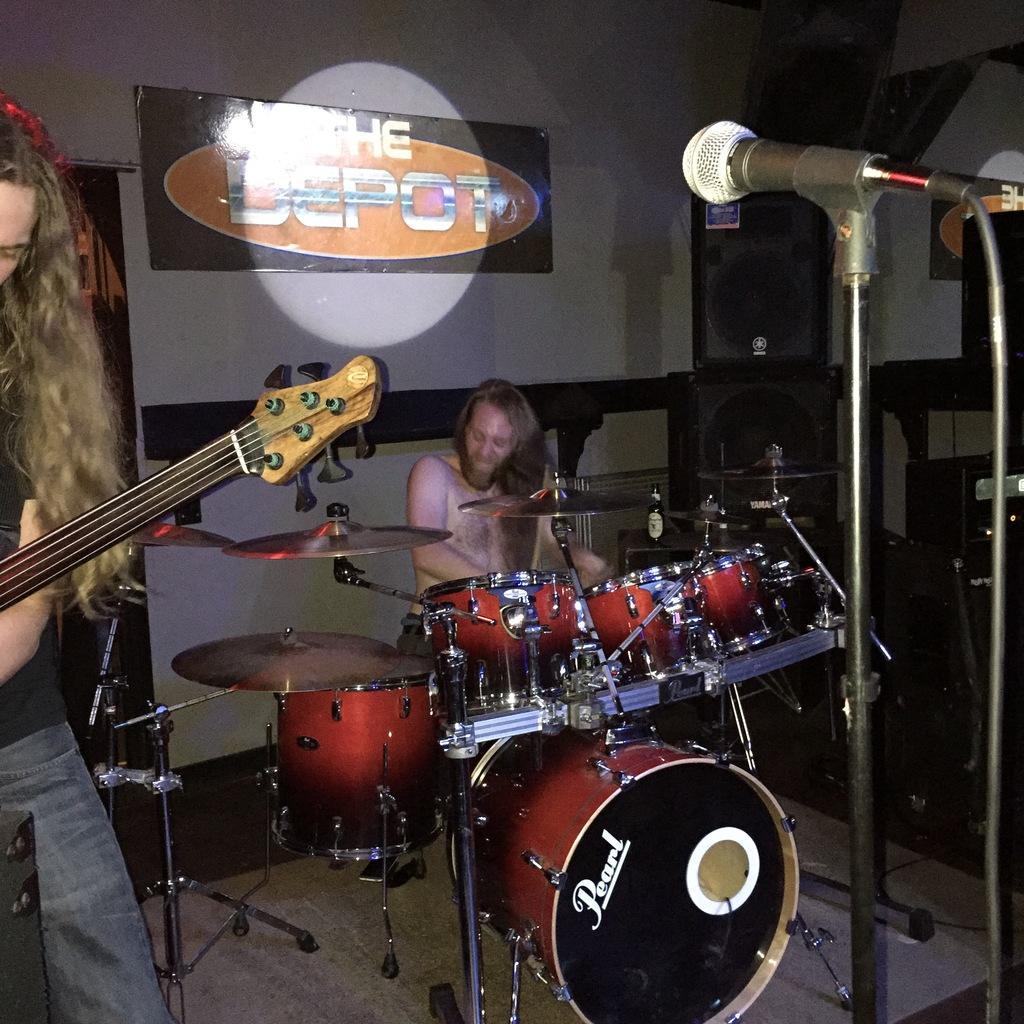Can you describe this image briefly? In this picture we can see two men playing guitar and drums and in front of them we have mics and in background we can see screen with banner, speakers. 